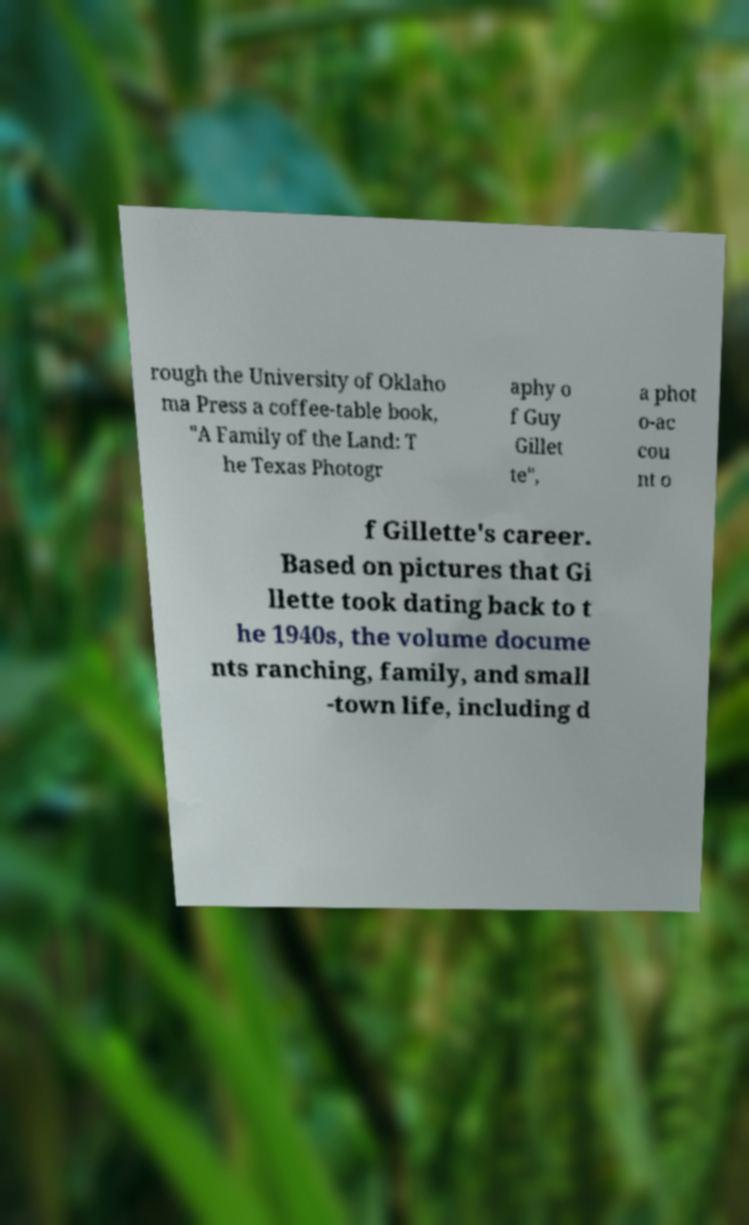Could you assist in decoding the text presented in this image and type it out clearly? rough the University of Oklaho ma Press a coffee-table book, "A Family of the Land: T he Texas Photogr aphy o f Guy Gillet te", a phot o-ac cou nt o f Gillette's career. Based on pictures that Gi llette took dating back to t he 1940s, the volume docume nts ranching, family, and small -town life, including d 